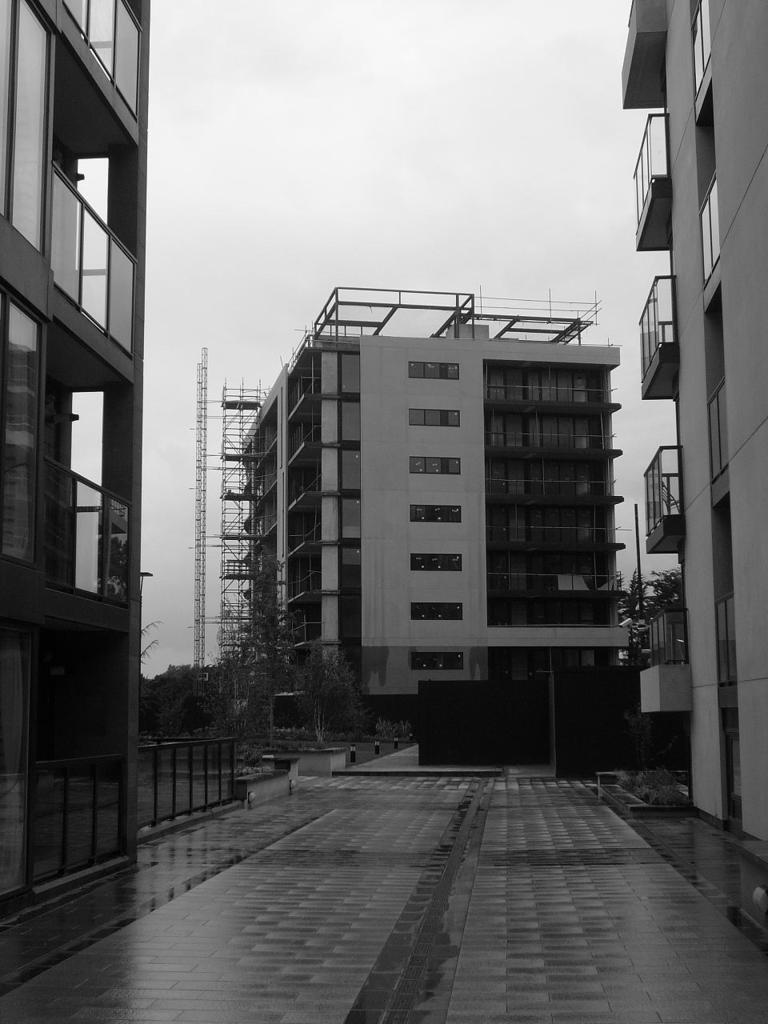What can be seen in the image that people might walk on? There is a path in the image that people might walk on. What is located beside the path for safety or support? There is: There is a railing beside the path for safety or support. What can be seen in the distance in the image? There are buildings and trees in the background of the image. What is visible at the top of the image? The sky is visible at the top of the image. What type of silverware is being used on the stage in the image? There is no stage, silverware, or any reference to a performance in the image. 